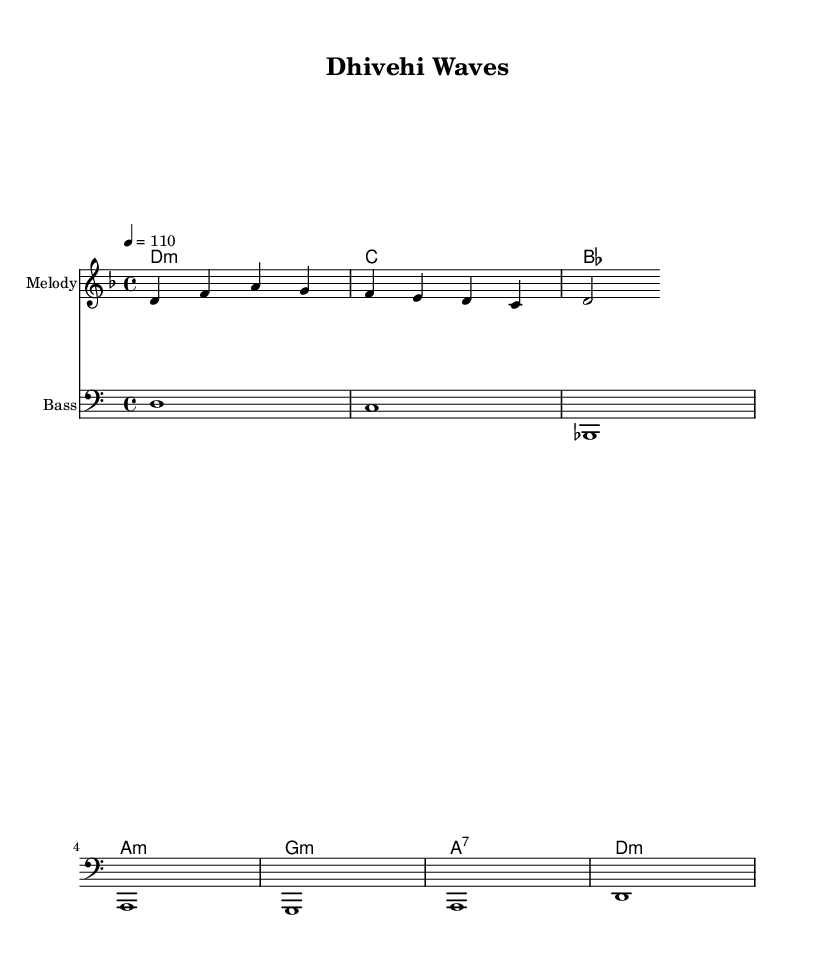What is the key signature of this music? The key signature is identified on the staff at the beginning of the piece. In this music, it is indicated as D minor, which corresponds to one flat (B♭).
Answer: D minor What is the time signature of this music? The time signature is found at the beginning of the score. It shows that each measure has four beats, indicating a 4/4 signature.
Answer: 4/4 What is the tempo marking of the piece? The tempo marking is shown in beats per minute at the beginning ("4 = 110"). This indicates the speed of the music, which is set to 110 beats per minute.
Answer: 110 What are the first three notes of the melody? The first three notes of the melody can be found at the start of the melody line, which are D, F, A.
Answer: D, F, A How many measures are there in the melody? By counting the distinct groups of notes divided by the bar lines in the melody staff, we find that there are a total of three measures.
Answer: 3 What is the chord that accompanies the first measure? The chord for the first measure is assigned in the chord progression, indicating that it is a D minor chord as notated with "d:m".
Answer: D minor Which section contains ambient sounds in this fusion piece? The piece is characterized by its fusion style, which typically includes additional electronic elements blending with traditional motifs. While not explicitly shown in this music sheet, the term "fusion" indicates these elements are implied in the composition itself.
Answer: Electronic elements 